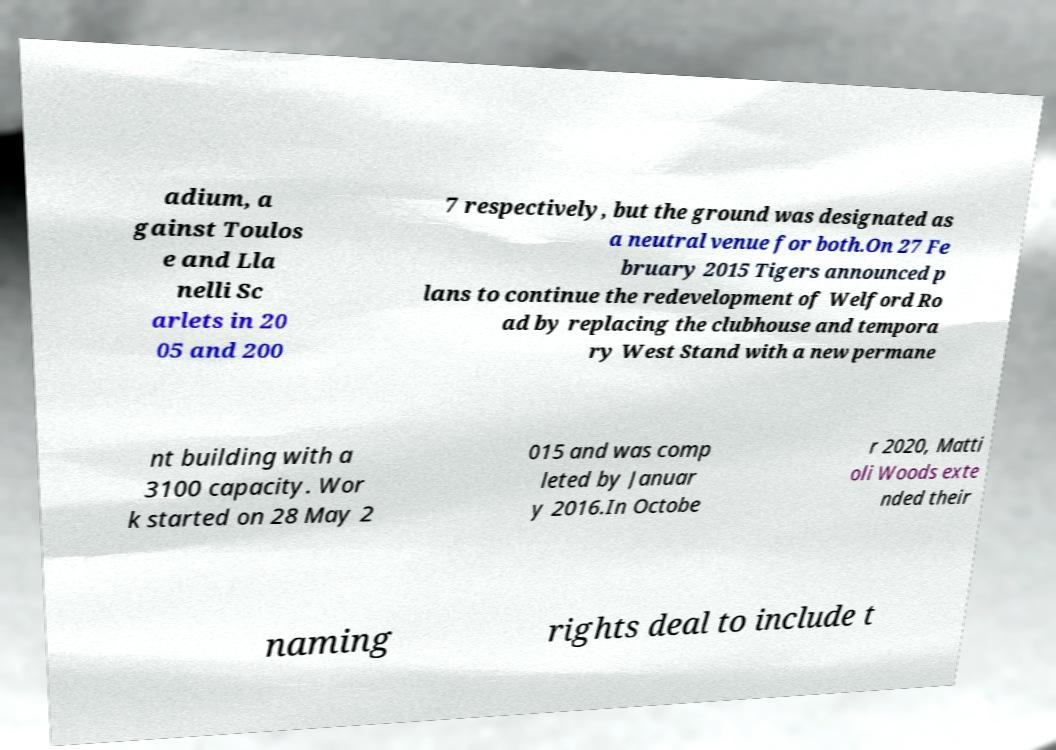Could you assist in decoding the text presented in this image and type it out clearly? adium, a gainst Toulos e and Lla nelli Sc arlets in 20 05 and 200 7 respectively, but the ground was designated as a neutral venue for both.On 27 Fe bruary 2015 Tigers announced p lans to continue the redevelopment of Welford Ro ad by replacing the clubhouse and tempora ry West Stand with a new permane nt building with a 3100 capacity. Wor k started on 28 May 2 015 and was comp leted by Januar y 2016.In Octobe r 2020, Matti oli Woods exte nded their naming rights deal to include t 